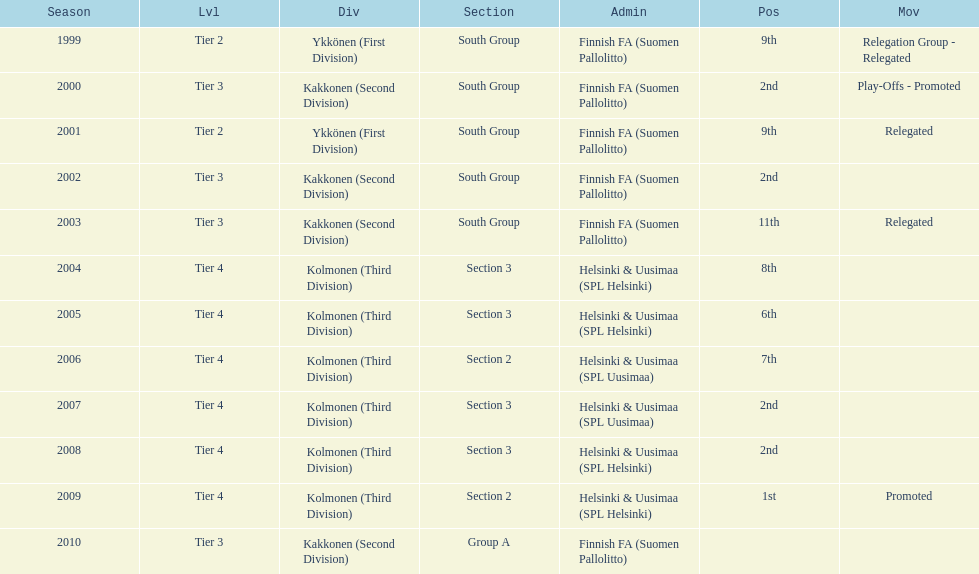Of the third division, how many were in section3? 4. 